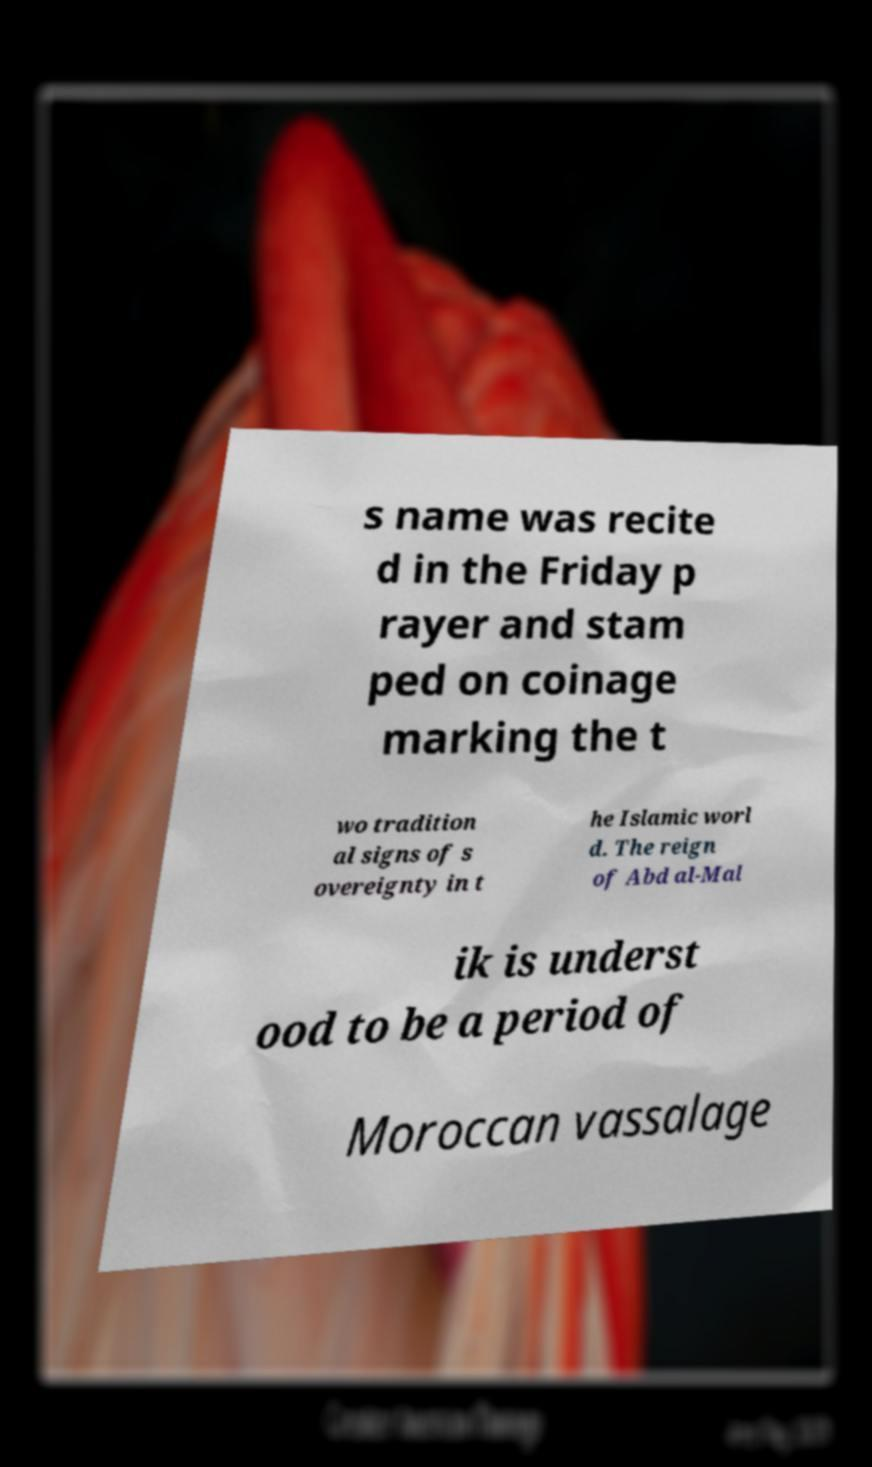Please read and relay the text visible in this image. What does it say? s name was recite d in the Friday p rayer and stam ped on coinage marking the t wo tradition al signs of s overeignty in t he Islamic worl d. The reign of Abd al-Mal ik is underst ood to be a period of Moroccan vassalage 